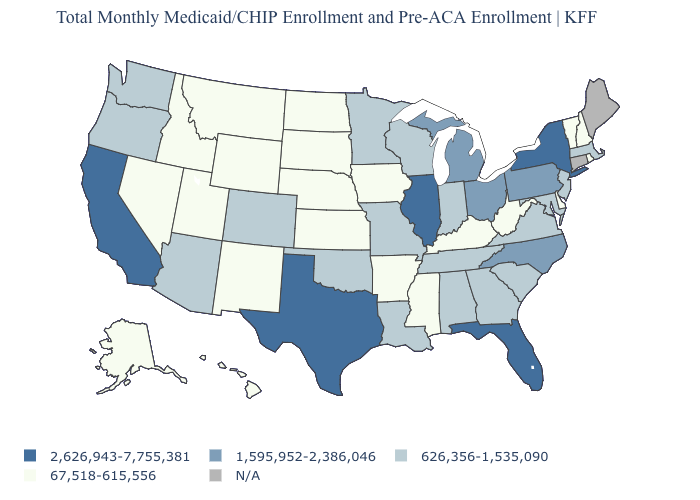Among the states that border Arkansas , which have the highest value?
Concise answer only. Texas. Name the states that have a value in the range 626,356-1,535,090?
Answer briefly. Alabama, Arizona, Colorado, Georgia, Indiana, Louisiana, Maryland, Massachusetts, Minnesota, Missouri, New Jersey, Oklahoma, Oregon, South Carolina, Tennessee, Virginia, Washington, Wisconsin. What is the value of Pennsylvania?
Give a very brief answer. 1,595,952-2,386,046. Among the states that border Kentucky , which have the highest value?
Write a very short answer. Illinois. What is the value of Maryland?
Keep it brief. 626,356-1,535,090. What is the value of Mississippi?
Keep it brief. 67,518-615,556. Among the states that border New Hampshire , which have the lowest value?
Short answer required. Vermont. Does Massachusetts have the lowest value in the Northeast?
Quick response, please. No. Name the states that have a value in the range 2,626,943-7,755,381?
Give a very brief answer. California, Florida, Illinois, New York, Texas. Among the states that border North Carolina , which have the highest value?
Short answer required. Georgia, South Carolina, Tennessee, Virginia. What is the lowest value in states that border Arkansas?
Answer briefly. 67,518-615,556. Among the states that border New Jersey , which have the lowest value?
Quick response, please. Delaware. What is the highest value in states that border Tennessee?
Be succinct. 1,595,952-2,386,046. What is the value of North Carolina?
Short answer required. 1,595,952-2,386,046. 